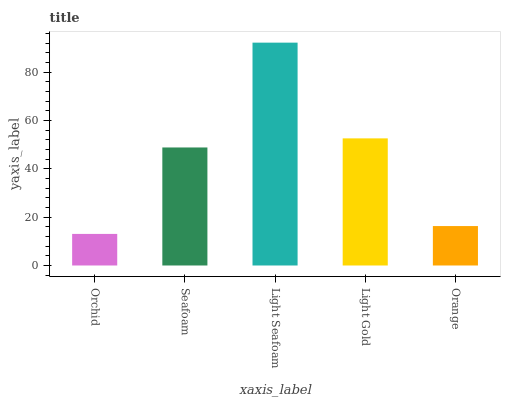Is Orchid the minimum?
Answer yes or no. Yes. Is Light Seafoam the maximum?
Answer yes or no. Yes. Is Seafoam the minimum?
Answer yes or no. No. Is Seafoam the maximum?
Answer yes or no. No. Is Seafoam greater than Orchid?
Answer yes or no. Yes. Is Orchid less than Seafoam?
Answer yes or no. Yes. Is Orchid greater than Seafoam?
Answer yes or no. No. Is Seafoam less than Orchid?
Answer yes or no. No. Is Seafoam the high median?
Answer yes or no. Yes. Is Seafoam the low median?
Answer yes or no. Yes. Is Light Gold the high median?
Answer yes or no. No. Is Orchid the low median?
Answer yes or no. No. 